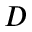<formula> <loc_0><loc_0><loc_500><loc_500>D</formula> 